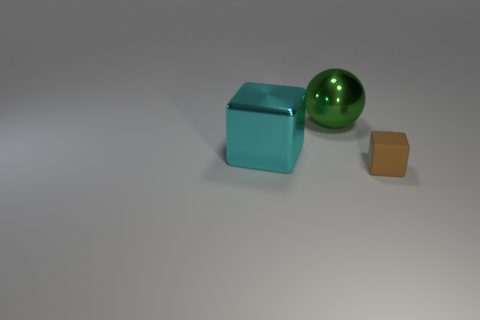Add 3 red cubes. How many objects exist? 6 Subtract all cubes. How many objects are left? 1 Add 1 balls. How many balls exist? 2 Subtract 0 brown balls. How many objects are left? 3 Subtract all spheres. Subtract all small things. How many objects are left? 1 Add 2 large green metallic things. How many large green metallic things are left? 3 